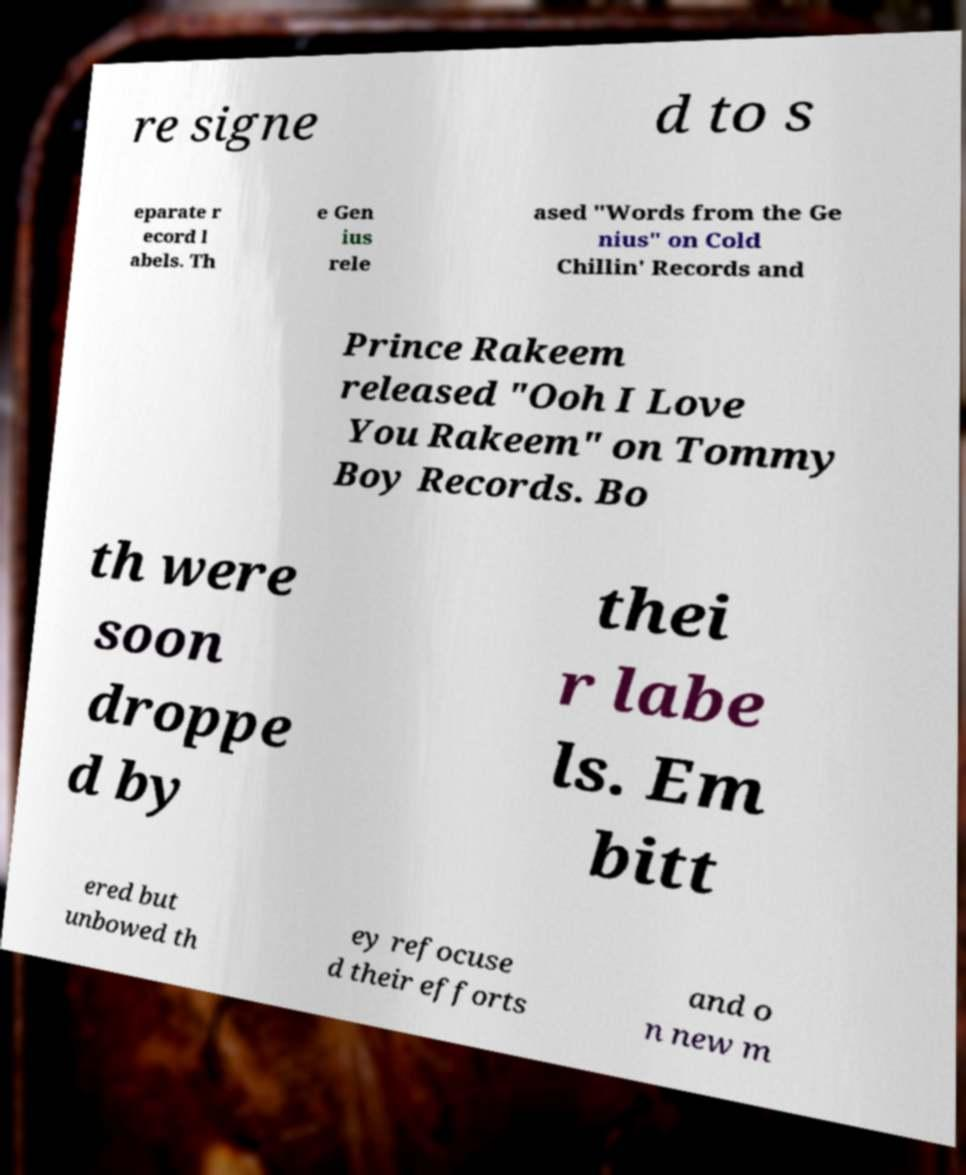Can you read and provide the text displayed in the image?This photo seems to have some interesting text. Can you extract and type it out for me? re signe d to s eparate r ecord l abels. Th e Gen ius rele ased "Words from the Ge nius" on Cold Chillin' Records and Prince Rakeem released "Ooh I Love You Rakeem" on Tommy Boy Records. Bo th were soon droppe d by thei r labe ls. Em bitt ered but unbowed th ey refocuse d their efforts and o n new m 